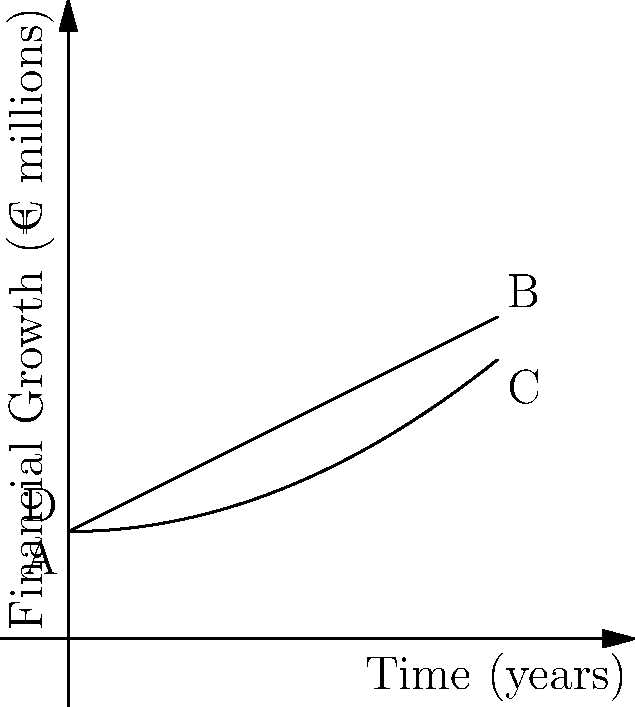The trapezoidal graph above represents the financial growth of a company after restructuring. The x-axis shows time in years, and the y-axis shows financial growth in millions of euros. If the area under the curve represents the total financial gain, calculate the total financial gain over the 4-year period. Round your answer to the nearest million euros. To calculate the area of the trapezoid, we'll use the formula:

$$ A = \frac{1}{2}(b_1 + b_2)h $$

Where:
$A$ = Area
$b_1$ = Length of one parallel side
$b_2$ = Length of the other parallel side
$h$ = Height (perpendicular distance between parallel sides)

Step 1: Identify the values
$b_1$ (initial value) = €1 million
$b_2$ (final value) = €3 million
$h$ (time period) = 4 years

Step 2: Apply the formula
$$ A = \frac{1}{2}(1 + 3) \times 4 $$
$$ A = \frac{1}{2}(4) \times 4 $$
$$ A = 2 \times 4 $$
$$ A = 8 $$

Step 3: Interpret the result
The total area is 8 square units, where each unit represents €1 million over 1 year.

Therefore, the total financial gain over the 4-year period is €8 million.
Answer: €8 million 